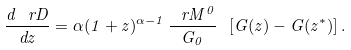Convert formula to latex. <formula><loc_0><loc_0><loc_500><loc_500>\frac { d \ r D } { d z } = \alpha ( 1 + z ) ^ { \alpha - 1 } \, \frac { \ r M ^ { 0 } } { G _ { 0 } } \ [ G ( z ) - G ( z ^ { * } ) ] \, .</formula> 